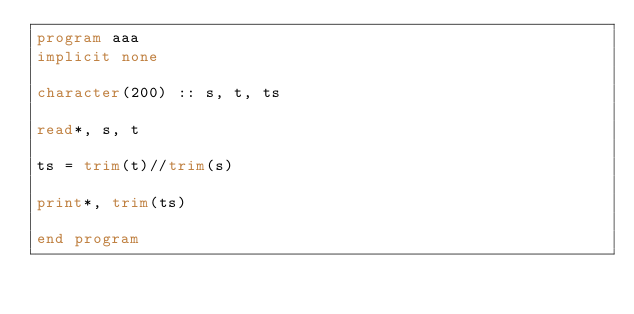Convert code to text. <code><loc_0><loc_0><loc_500><loc_500><_FORTRAN_>program aaa
implicit none

character(200) :: s, t, ts

read*, s, t

ts = trim(t)//trim(s)

print*, trim(ts)

end program</code> 